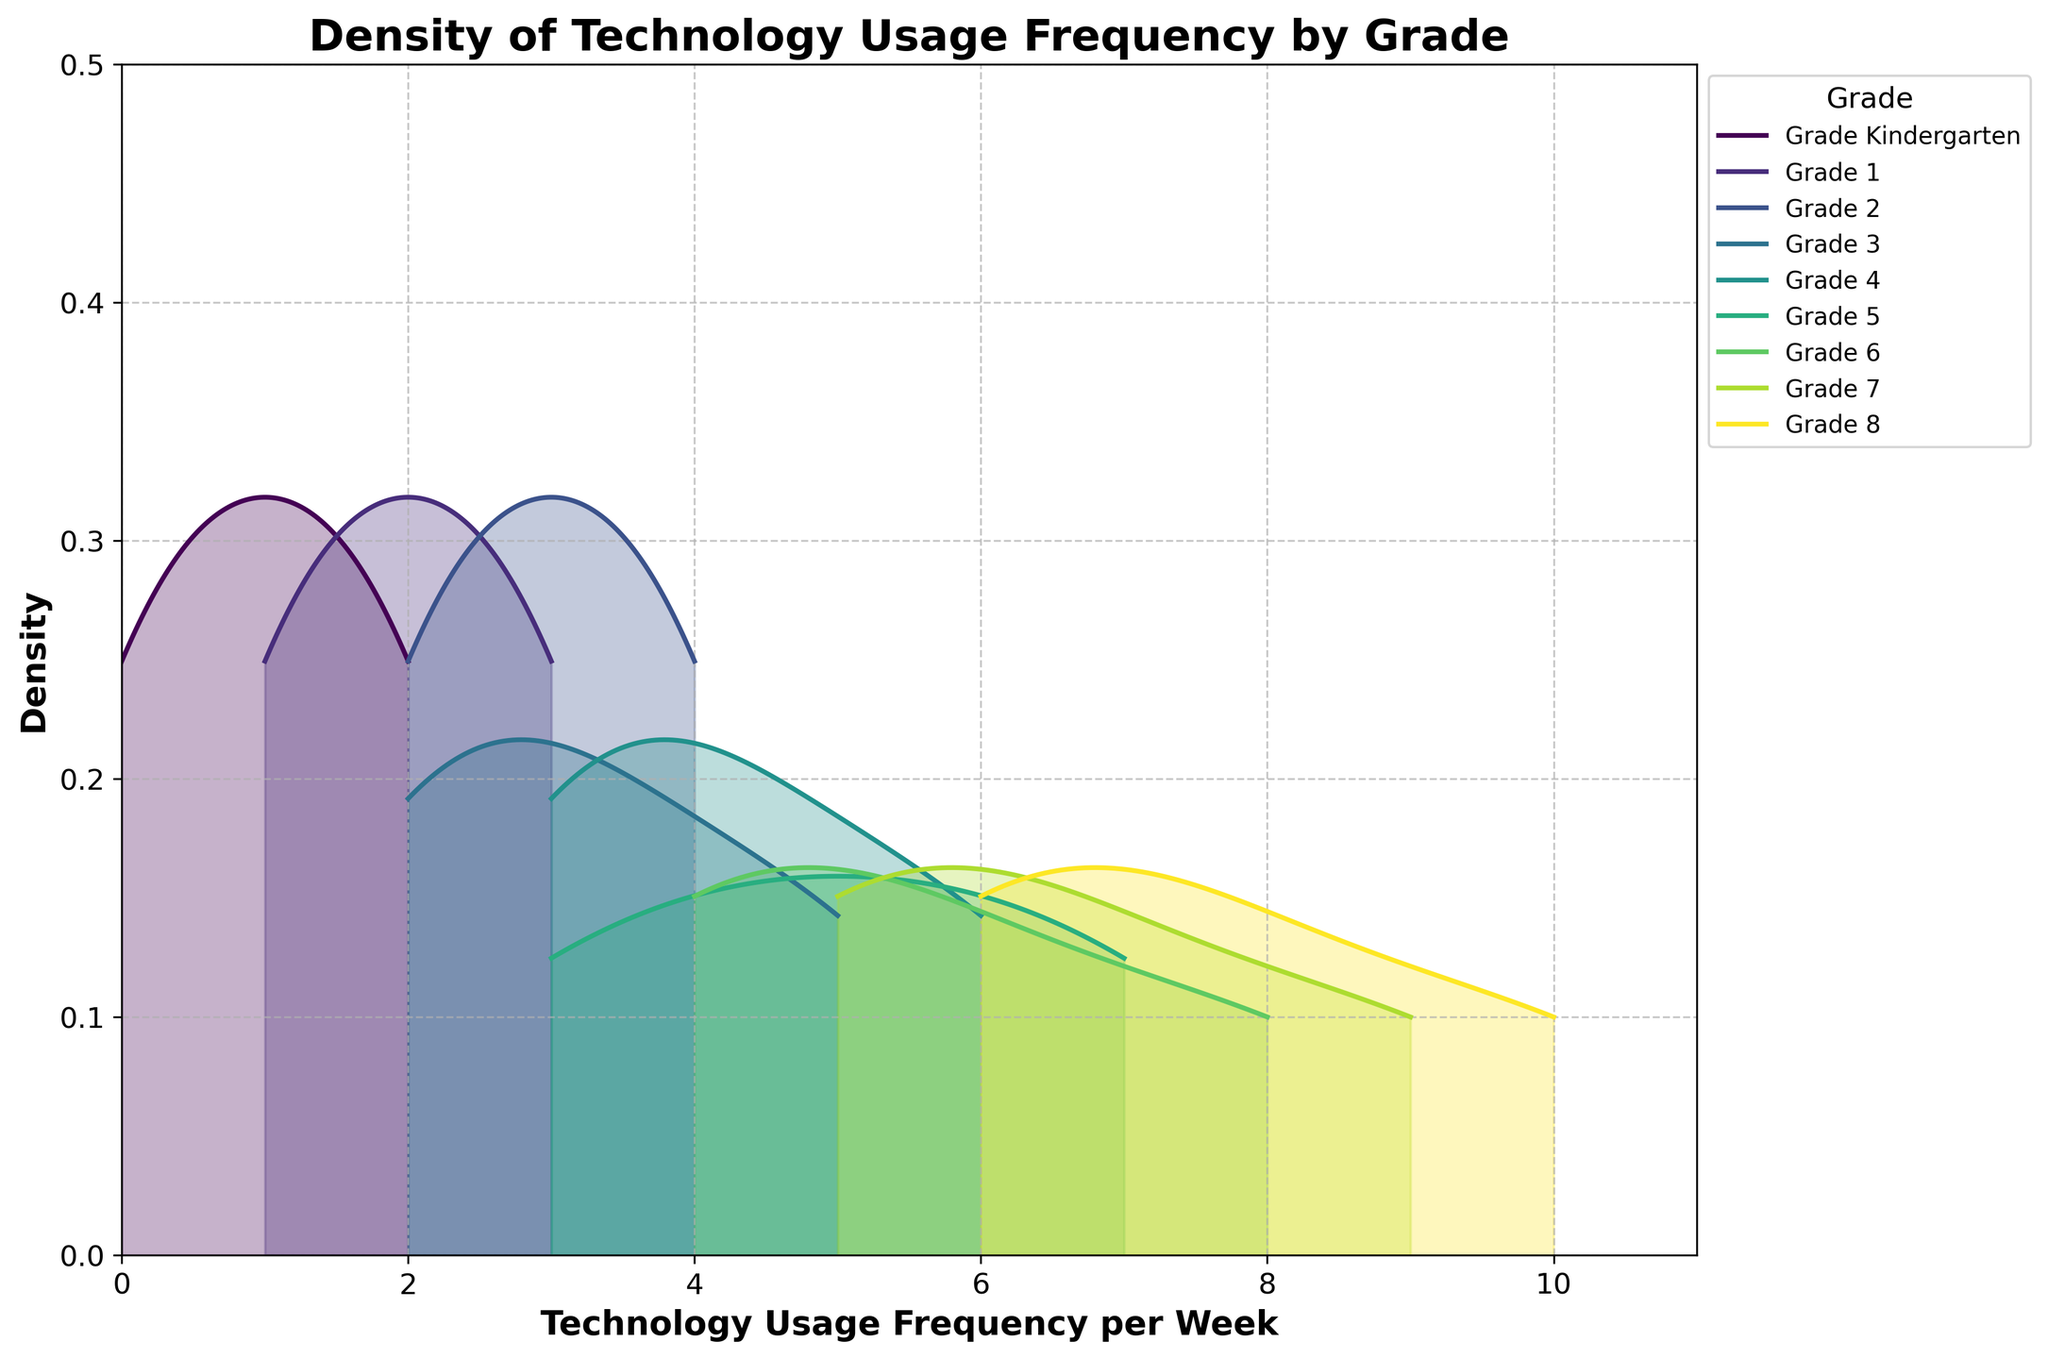How many grades are compared in the figure? The x-axis and legend indicate the grades, listing them as 'Kindergarten' through '8'. By tallying these categories, we find nine distinct grades included in the comparison.
Answer: Nine What is the title of the figure? The title is prominently displayed at the top of the figure, reading "Density of Technology Usage Frequency by Grade".
Answer: Density of Technology Usage Frequency by Grade Which grade appears to have the highest peak density for technology usage frequency? By examining the figure, one can see the peaks of the density plots for each grade. The grade with the highest peak is easily identifiable.
Answer: Grade 8 What range of technology usage frequency appears for Kindergarten compared to Grade 8? For this, observe the x-axis range of the density plots for both Kindergarten and Grade 8. Kindergarten ranges from 0 to 2, while Grade 8 ranges from 6 to 10.
Answer: Kindergarten: 0-2, Grade 8: 6-10 Does any grade have a density curve that spans the entire x-axis range from 0 to 10? Analyzing the individual density curves, none of them covers the entire range. All curves are focused on specific segments of the x-axis, indicating varied usage frequencies for different grades.
Answer: No Which grade's technology usage frequency has the most spread or variability? The spread of data is indicated by the width of the density curve. Grade 8's density curve is spread across a range of values, indicating significant variability compared to more concentrated grades like Kindergarten.
Answer: Grade 8 Between Grades 4 and 6, which grade shows higher technology usage frequency peaks? By assessing the peak heights of the density curves for Grades 4 and 6, it's clear that Grade 6 has higher peaks compared to Grade 4.
Answer: Grade 6 What is the lowest usage frequency observed for any grade? The lowest point on the x-axis intersecting any density curve should be identified. The Kindergarten plot starts from 0.
Answer: 0 How does the usage frequency distribution for Grade 2 compare to that of Grade 5? By comparing the density curves of both grades, Grade 2's frequency plot ranges narrowly from 2 to 4, while Grade 5 covers a broader range from 3 to 7.
Answer: Grade 2: 2-4, Grade 5: 3-7 